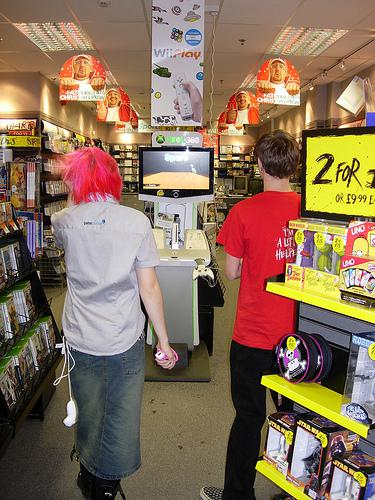Question: what color was the man wearing?
Choices:
A. Blue.
B. Red.
C. Green.
D. Yellow.
Answer with the letter. Answer: B Question: what color was the women wearing?
Choices:
A. White.
B. Gray.
C. Black.
D. Yellow.
Answer with the letter. Answer: B Question: who was talking on the phone?
Choices:
A. The women.
B. The men.
C. The woman.
D. The man.
Answer with the letter. Answer: A Question: where was this pictrue taken?
Choices:
A. Stroe.
B. Party.
C. Graduation.
D. Wedding.
Answer with the letter. Answer: A Question: how many people in the picture?
Choices:
A. 3.
B. 2.
C. 4.
D. 5.
Answer with the letter. Answer: B Question: why the people in the store?
Choices:
A. Buying.
B. Purchasing.
C. Selling.
D. Shopping.
Answer with the letter. Answer: D 